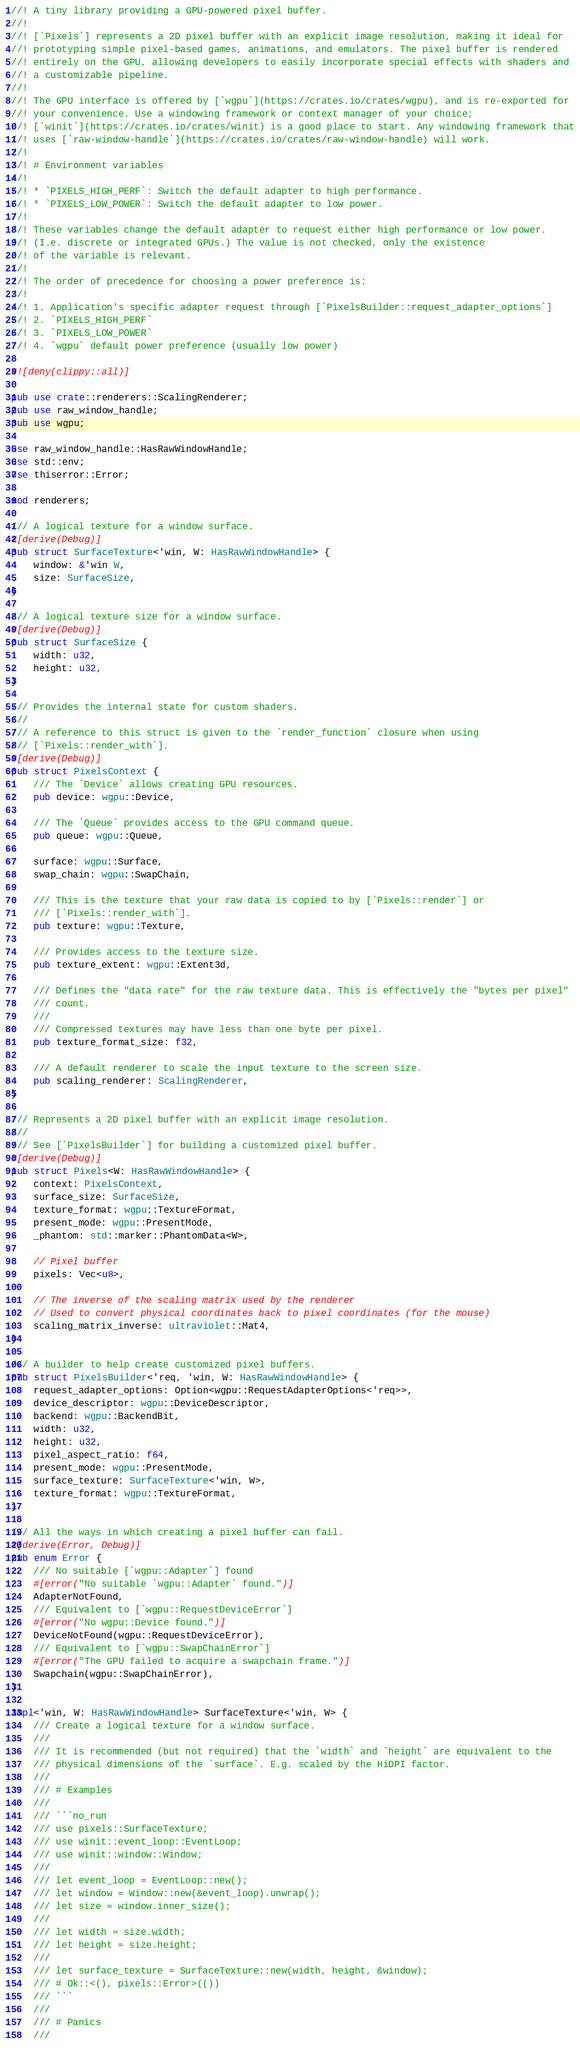Convert code to text. <code><loc_0><loc_0><loc_500><loc_500><_Rust_>//! A tiny library providing a GPU-powered pixel buffer.
//!
//! [`Pixels`] represents a 2D pixel buffer with an explicit image resolution, making it ideal for
//! prototyping simple pixel-based games, animations, and emulators. The pixel buffer is rendered
//! entirely on the GPU, allowing developers to easily incorporate special effects with shaders and
//! a customizable pipeline.
//!
//! The GPU interface is offered by [`wgpu`](https://crates.io/crates/wgpu), and is re-exported for
//! your convenience. Use a windowing framework or context manager of your choice;
//! [`winit`](https://crates.io/crates/winit) is a good place to start. Any windowing framework that
//! uses [`raw-window-handle`](https://crates.io/crates/raw-window-handle) will work.
//!
//! # Environment variables
//!
//! * `PIXELS_HIGH_PERF`: Switch the default adapter to high performance.
//! * `PIXELS_LOW_POWER`: Switch the default adapter to low power.
//!
//! These variables change the default adapter to request either high performance or low power.
//! (I.e. discrete or integrated GPUs.) The value is not checked, only the existence
//! of the variable is relevant.
//!
//! The order of precedence for choosing a power preference is:
//!
//! 1. Application's specific adapter request through [`PixelsBuilder::request_adapter_options`]
//! 2. `PIXELS_HIGH_PERF`
//! 3. `PIXELS_LOW_POWER`
//! 4. `wgpu` default power preference (usually low power)

#![deny(clippy::all)]

pub use crate::renderers::ScalingRenderer;
pub use raw_window_handle;
pub use wgpu;

use raw_window_handle::HasRawWindowHandle;
use std::env;
use thiserror::Error;

mod renderers;

/// A logical texture for a window surface.
#[derive(Debug)]
pub struct SurfaceTexture<'win, W: HasRawWindowHandle> {
    window: &'win W,
    size: SurfaceSize,
}

/// A logical texture size for a window surface.
#[derive(Debug)]
pub struct SurfaceSize {
    width: u32,
    height: u32,
}

/// Provides the internal state for custom shaders.
///
/// A reference to this struct is given to the `render_function` closure when using
/// [`Pixels::render_with`].
#[derive(Debug)]
pub struct PixelsContext {
    /// The `Device` allows creating GPU resources.
    pub device: wgpu::Device,

    /// The `Queue` provides access to the GPU command queue.
    pub queue: wgpu::Queue,

    surface: wgpu::Surface,
    swap_chain: wgpu::SwapChain,

    /// This is the texture that your raw data is copied to by [`Pixels::render`] or
    /// [`Pixels::render_with`].
    pub texture: wgpu::Texture,

    /// Provides access to the texture size.
    pub texture_extent: wgpu::Extent3d,

    /// Defines the "data rate" for the raw texture data. This is effectively the "bytes per pixel"
    /// count.
    ///
    /// Compressed textures may have less than one byte per pixel.
    pub texture_format_size: f32,

    /// A default renderer to scale the input texture to the screen size.
    pub scaling_renderer: ScalingRenderer,
}

/// Represents a 2D pixel buffer with an explicit image resolution.
///
/// See [`PixelsBuilder`] for building a customized pixel buffer.
#[derive(Debug)]
pub struct Pixels<W: HasRawWindowHandle> {
    context: PixelsContext,
    surface_size: SurfaceSize,
    texture_format: wgpu::TextureFormat,
    present_mode: wgpu::PresentMode,
    _phantom: std::marker::PhantomData<W>,

    // Pixel buffer
    pixels: Vec<u8>,

    // The inverse of the scaling matrix used by the renderer
    // Used to convert physical coordinates back to pixel coordinates (for the mouse)
    scaling_matrix_inverse: ultraviolet::Mat4,
}

/// A builder to help create customized pixel buffers.
pub struct PixelsBuilder<'req, 'win, W: HasRawWindowHandle> {
    request_adapter_options: Option<wgpu::RequestAdapterOptions<'req>>,
    device_descriptor: wgpu::DeviceDescriptor,
    backend: wgpu::BackendBit,
    width: u32,
    height: u32,
    pixel_aspect_ratio: f64,
    present_mode: wgpu::PresentMode,
    surface_texture: SurfaceTexture<'win, W>,
    texture_format: wgpu::TextureFormat,
}

/// All the ways in which creating a pixel buffer can fail.
#[derive(Error, Debug)]
pub enum Error {
    /// No suitable [`wgpu::Adapter`] found
    #[error("No suitable `wgpu::Adapter` found.")]
    AdapterNotFound,
    /// Equivalent to [`wgpu::RequestDeviceError`]
    #[error("No wgpu::Device found.")]
    DeviceNotFound(wgpu::RequestDeviceError),
    /// Equivalent to [`wgpu::SwapChainError`]
    #[error("The GPU failed to acquire a swapchain frame.")]
    Swapchain(wgpu::SwapChainError),
}

impl<'win, W: HasRawWindowHandle> SurfaceTexture<'win, W> {
    /// Create a logical texture for a window surface.
    ///
    /// It is recommended (but not required) that the `width` and `height` are equivalent to the
    /// physical dimensions of the `surface`. E.g. scaled by the HiDPI factor.
    ///
    /// # Examples
    ///
    /// ```no_run
    /// use pixels::SurfaceTexture;
    /// use winit::event_loop::EventLoop;
    /// use winit::window::Window;
    ///
    /// let event_loop = EventLoop::new();
    /// let window = Window::new(&event_loop).unwrap();
    /// let size = window.inner_size();
    ///
    /// let width = size.width;
    /// let height = size.height;
    ///
    /// let surface_texture = SurfaceTexture::new(width, height, &window);
    /// # Ok::<(), pixels::Error>(())
    /// ```
    ///
    /// # Panics
    ///</code> 